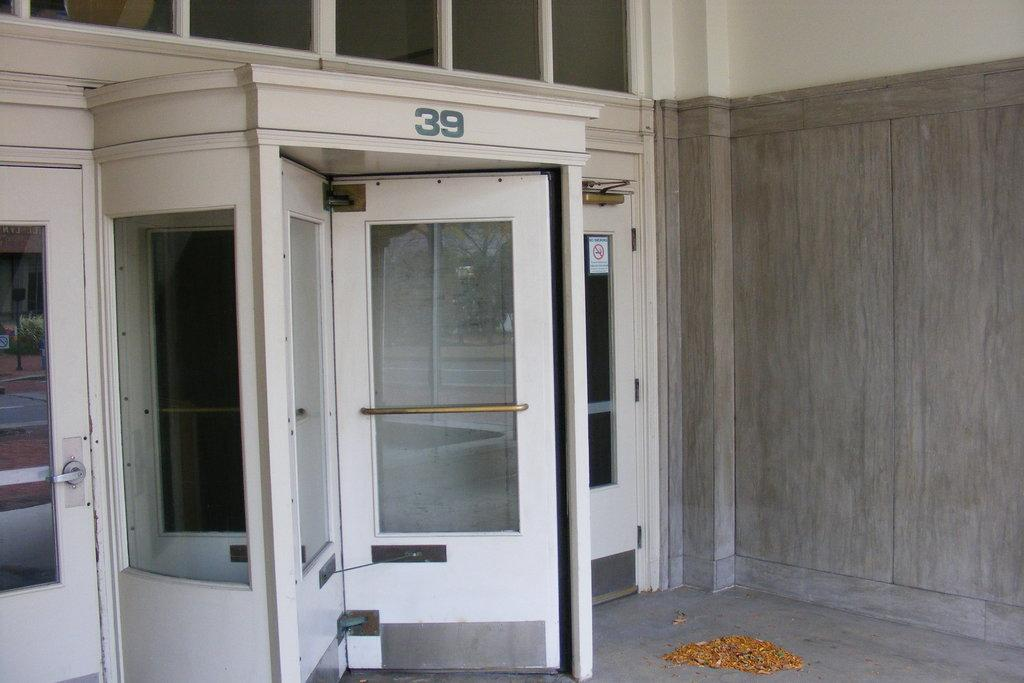<image>
Create a compact narrative representing the image presented. a building with a revolving door and the number 39 above it 